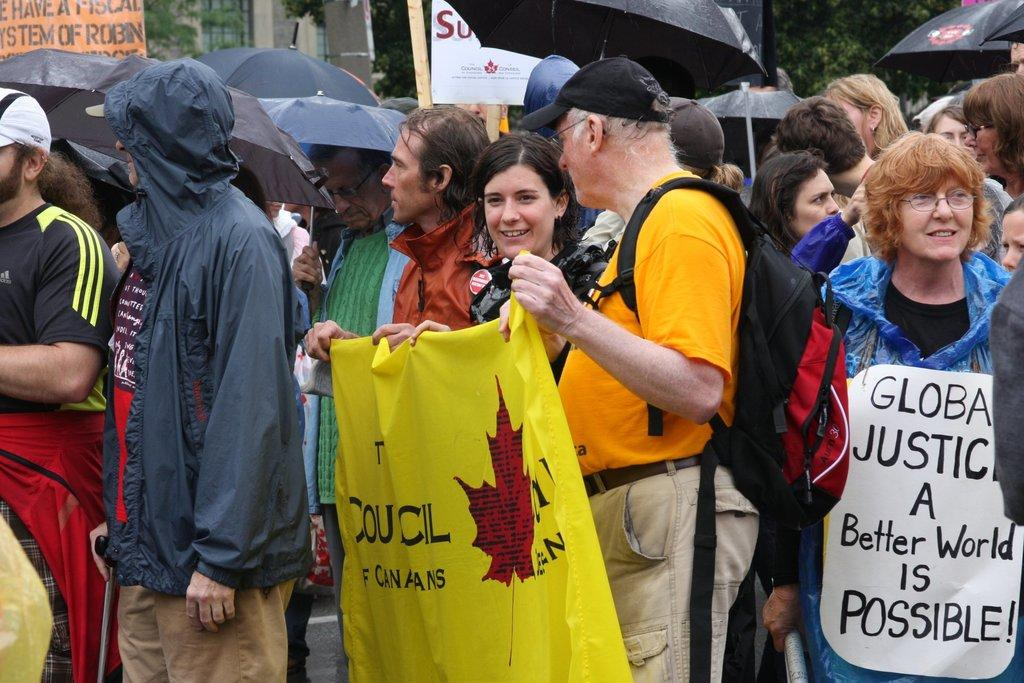How many people are present in the image? There are many people in the image. What are the people wearing in the image? The people are wearing raincoats. What are the people holding in the image? The people are holding umbrellas and banners. What type of event is taking place in the image? The scene appears to be a rally. What can be seen in the background of the image? There are trees and buildings in the background of the image. What type of cannon is being fired during the process in the image? There is no cannon present in the image, and no process is taking place. How many people are seen kissing in the image? There are no people kissing in the image. 